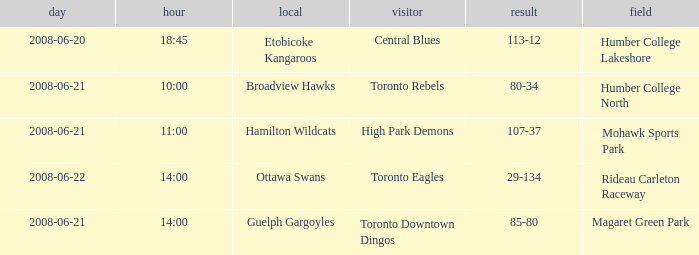What is the Away with a Ground that is humber college lakeshore? Central Blues. 